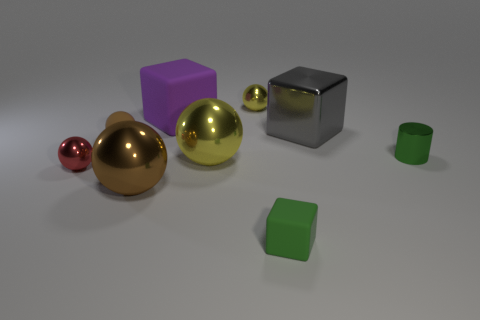There is a small matte object in front of the large metal ball that is left of the large object that is behind the big gray thing; what shape is it?
Provide a short and direct response. Cube. Is the number of big brown spheres greater than the number of gray spheres?
Provide a short and direct response. Yes. There is a tiny green thing that is the same shape as the gray metallic object; what material is it?
Provide a succinct answer. Rubber. Is the material of the purple thing the same as the green cylinder?
Your answer should be compact. No. Is the number of gray shiny things behind the large purple matte cube greater than the number of large green objects?
Ensure brevity in your answer.  No. The yellow ball that is on the left side of the tiny yellow sphere on the left side of the small matte object that is right of the big purple matte thing is made of what material?
Make the answer very short. Metal. What number of objects are either purple cubes or small matte things to the left of the green rubber block?
Make the answer very short. 2. Do the matte block on the left side of the small yellow metal thing and the cylinder have the same color?
Offer a very short reply. No. Is the number of tiny red metallic objects that are behind the small green cylinder greater than the number of tiny brown matte objects on the right side of the purple rubber thing?
Ensure brevity in your answer.  No. Are there any other things that are the same color as the tiny rubber sphere?
Your response must be concise. Yes. 